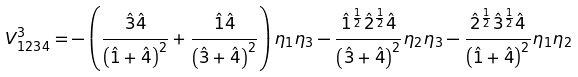Convert formula to latex. <formula><loc_0><loc_0><loc_500><loc_500>V _ { 1 2 3 4 } ^ { 3 } = - \left ( \frac { \hat { 3 } \hat { 4 } } { \left ( \hat { 1 } + \hat { 4 } \right ) ^ { 2 } } + \frac { \hat { 1 } \hat { 4 } } { \left ( \hat { 3 } + \hat { 4 } \right ) ^ { 2 } } \right ) \eta _ { 1 } \eta _ { 3 } - \frac { \hat { 1 } ^ { \frac { 1 } { 2 } } \hat { 2 } ^ { \frac { 1 } { 2 } } \hat { 4 } } { \left ( \hat { 3 } + \hat { 4 } \right ) ^ { 2 } } \eta _ { 2 } \eta _ { 3 } - \frac { \hat { 2 } ^ { \frac { 1 } { 2 } } \hat { 3 } ^ { \frac { 1 } { 2 } } \hat { 4 } } { \left ( \hat { 1 } + \hat { 4 } \right ) ^ { 2 } } \eta _ { 1 } \eta _ { 2 }</formula> 